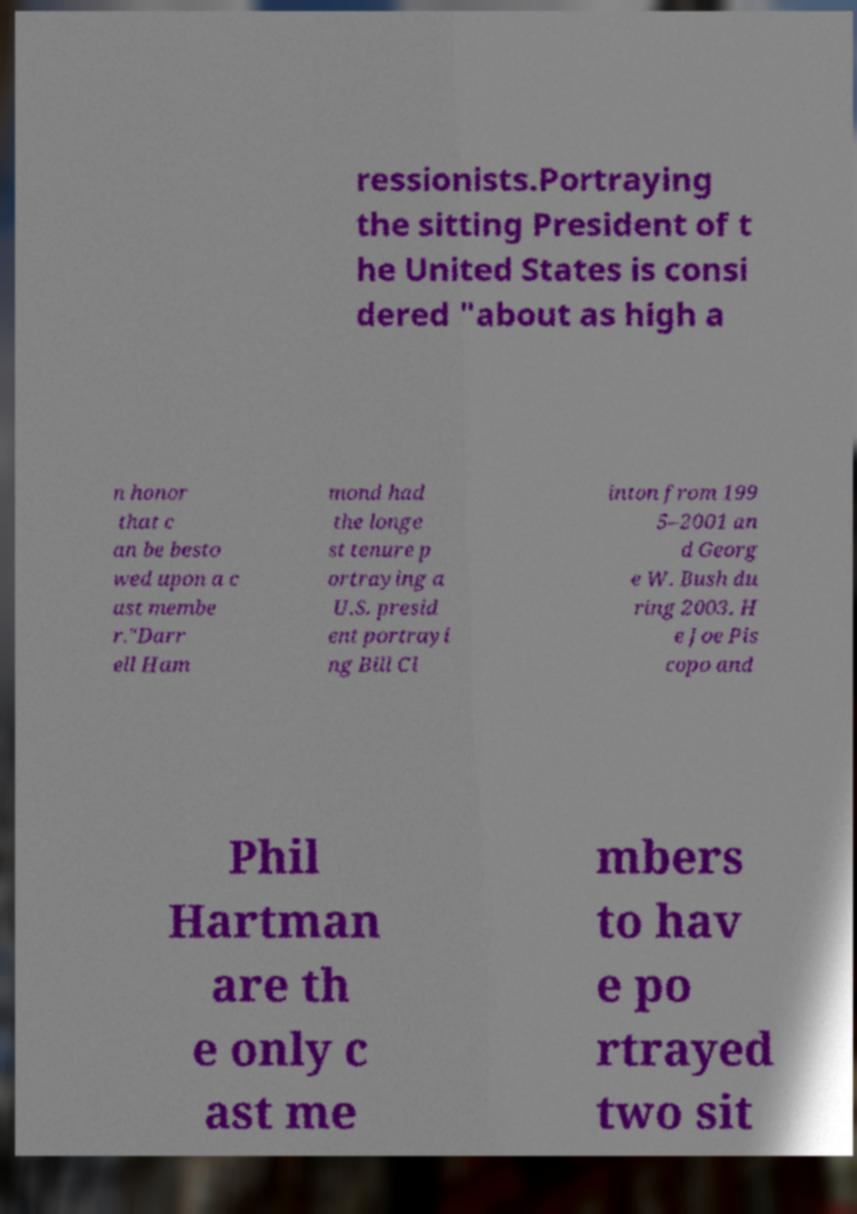For documentation purposes, I need the text within this image transcribed. Could you provide that? ressionists.Portraying the sitting President of t he United States is consi dered "about as high a n honor that c an be besto wed upon a c ast membe r."Darr ell Ham mond had the longe st tenure p ortraying a U.S. presid ent portrayi ng Bill Cl inton from 199 5–2001 an d Georg e W. Bush du ring 2003. H e Joe Pis copo and Phil Hartman are th e only c ast me mbers to hav e po rtrayed two sit 